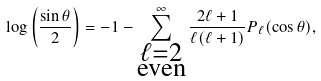<formula> <loc_0><loc_0><loc_500><loc_500>\log \left ( \frac { \sin \theta } { 2 } \right ) = - 1 - \sum _ { \substack { \ell = 2 \\ \text {even} } } ^ { \infty } \frac { 2 \ell + 1 } { \ell ( \ell + 1 ) } P _ { \ell } ( \cos \theta ) ,</formula> 